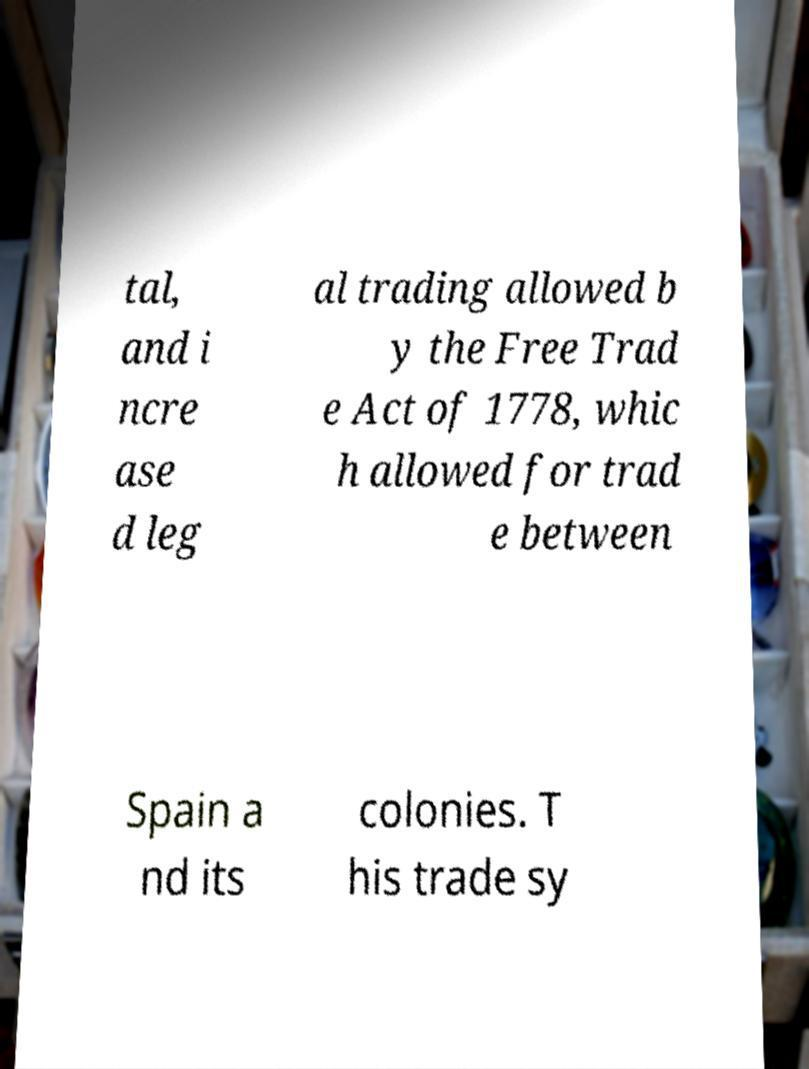Could you assist in decoding the text presented in this image and type it out clearly? tal, and i ncre ase d leg al trading allowed b y the Free Trad e Act of 1778, whic h allowed for trad e between Spain a nd its colonies. T his trade sy 